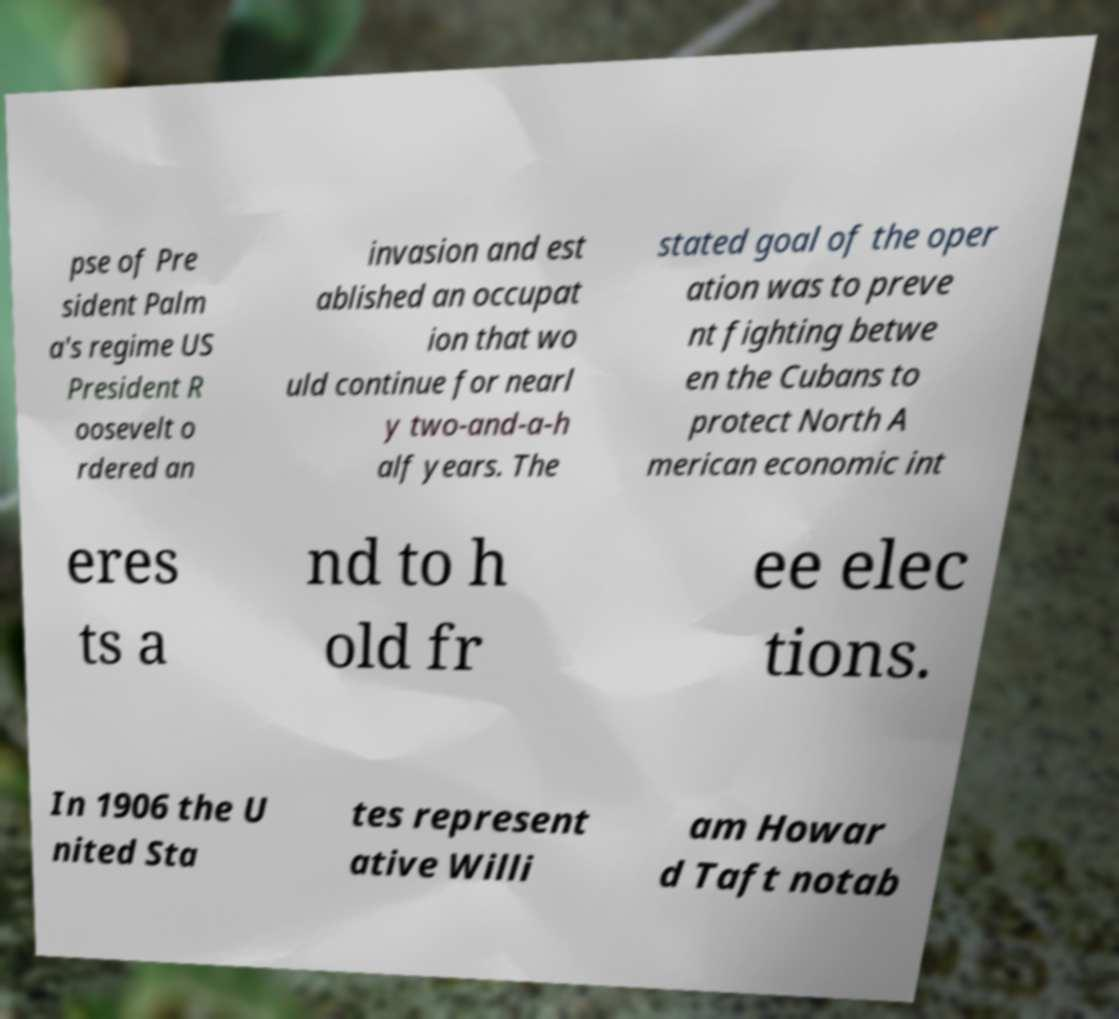Could you assist in decoding the text presented in this image and type it out clearly? pse of Pre sident Palm a's regime US President R oosevelt o rdered an invasion and est ablished an occupat ion that wo uld continue for nearl y two-and-a-h alf years. The stated goal of the oper ation was to preve nt fighting betwe en the Cubans to protect North A merican economic int eres ts a nd to h old fr ee elec tions. In 1906 the U nited Sta tes represent ative Willi am Howar d Taft notab 